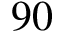Convert formula to latex. <formula><loc_0><loc_0><loc_500><loc_500>9 0</formula> 